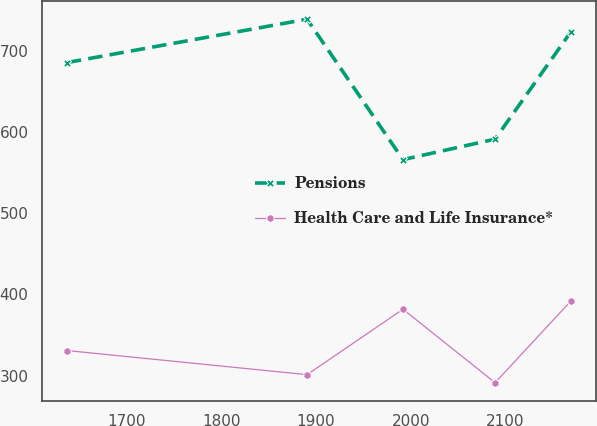Convert chart. <chart><loc_0><loc_0><loc_500><loc_500><line_chart><ecel><fcel>Pensions<fcel>Health Care and Life Insurance*<nl><fcel>1636.79<fcel>685.69<fcel>330.98<nl><fcel>1890.45<fcel>739.09<fcel>301.24<nl><fcel>1991.74<fcel>566.14<fcel>381.86<nl><fcel>2089<fcel>591.34<fcel>291.39<nl><fcel>2168.84<fcel>723.22<fcel>391.71<nl></chart> 